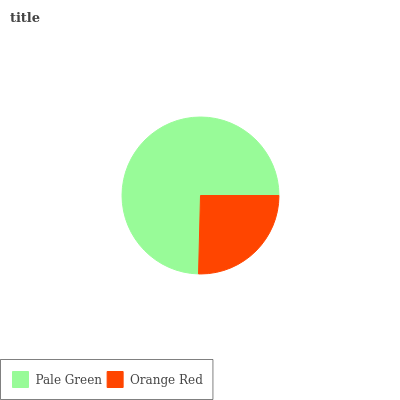Is Orange Red the minimum?
Answer yes or no. Yes. Is Pale Green the maximum?
Answer yes or no. Yes. Is Orange Red the maximum?
Answer yes or no. No. Is Pale Green greater than Orange Red?
Answer yes or no. Yes. Is Orange Red less than Pale Green?
Answer yes or no. Yes. Is Orange Red greater than Pale Green?
Answer yes or no. No. Is Pale Green less than Orange Red?
Answer yes or no. No. Is Pale Green the high median?
Answer yes or no. Yes. Is Orange Red the low median?
Answer yes or no. Yes. Is Orange Red the high median?
Answer yes or no. No. Is Pale Green the low median?
Answer yes or no. No. 